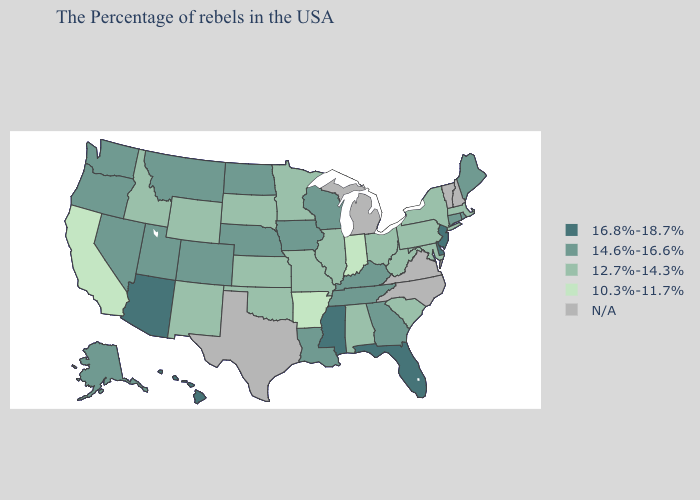What is the value of Minnesota?
Concise answer only. 12.7%-14.3%. What is the value of Mississippi?
Be succinct. 16.8%-18.7%. Among the states that border Wyoming , does Idaho have the highest value?
Write a very short answer. No. Name the states that have a value in the range 14.6%-16.6%?
Give a very brief answer. Maine, Rhode Island, Connecticut, Georgia, Kentucky, Tennessee, Wisconsin, Louisiana, Iowa, Nebraska, North Dakota, Colorado, Utah, Montana, Nevada, Washington, Oregon, Alaska. What is the value of Hawaii?
Short answer required. 16.8%-18.7%. Name the states that have a value in the range 10.3%-11.7%?
Short answer required. Indiana, Arkansas, California. What is the value of Kentucky?
Write a very short answer. 14.6%-16.6%. Name the states that have a value in the range N/A?
Quick response, please. New Hampshire, Vermont, Virginia, North Carolina, Michigan, Texas. What is the value of Mississippi?
Write a very short answer. 16.8%-18.7%. Which states have the highest value in the USA?
Give a very brief answer. New Jersey, Delaware, Florida, Mississippi, Arizona, Hawaii. Does the map have missing data?
Quick response, please. Yes. Among the states that border Virginia , which have the highest value?
Quick response, please. Kentucky, Tennessee. Which states hav the highest value in the Northeast?
Short answer required. New Jersey. Name the states that have a value in the range 16.8%-18.7%?
Give a very brief answer. New Jersey, Delaware, Florida, Mississippi, Arizona, Hawaii. 